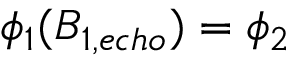<formula> <loc_0><loc_0><loc_500><loc_500>\phi _ { 1 } ( B _ { 1 , e c h o } ) = \phi _ { 2 }</formula> 